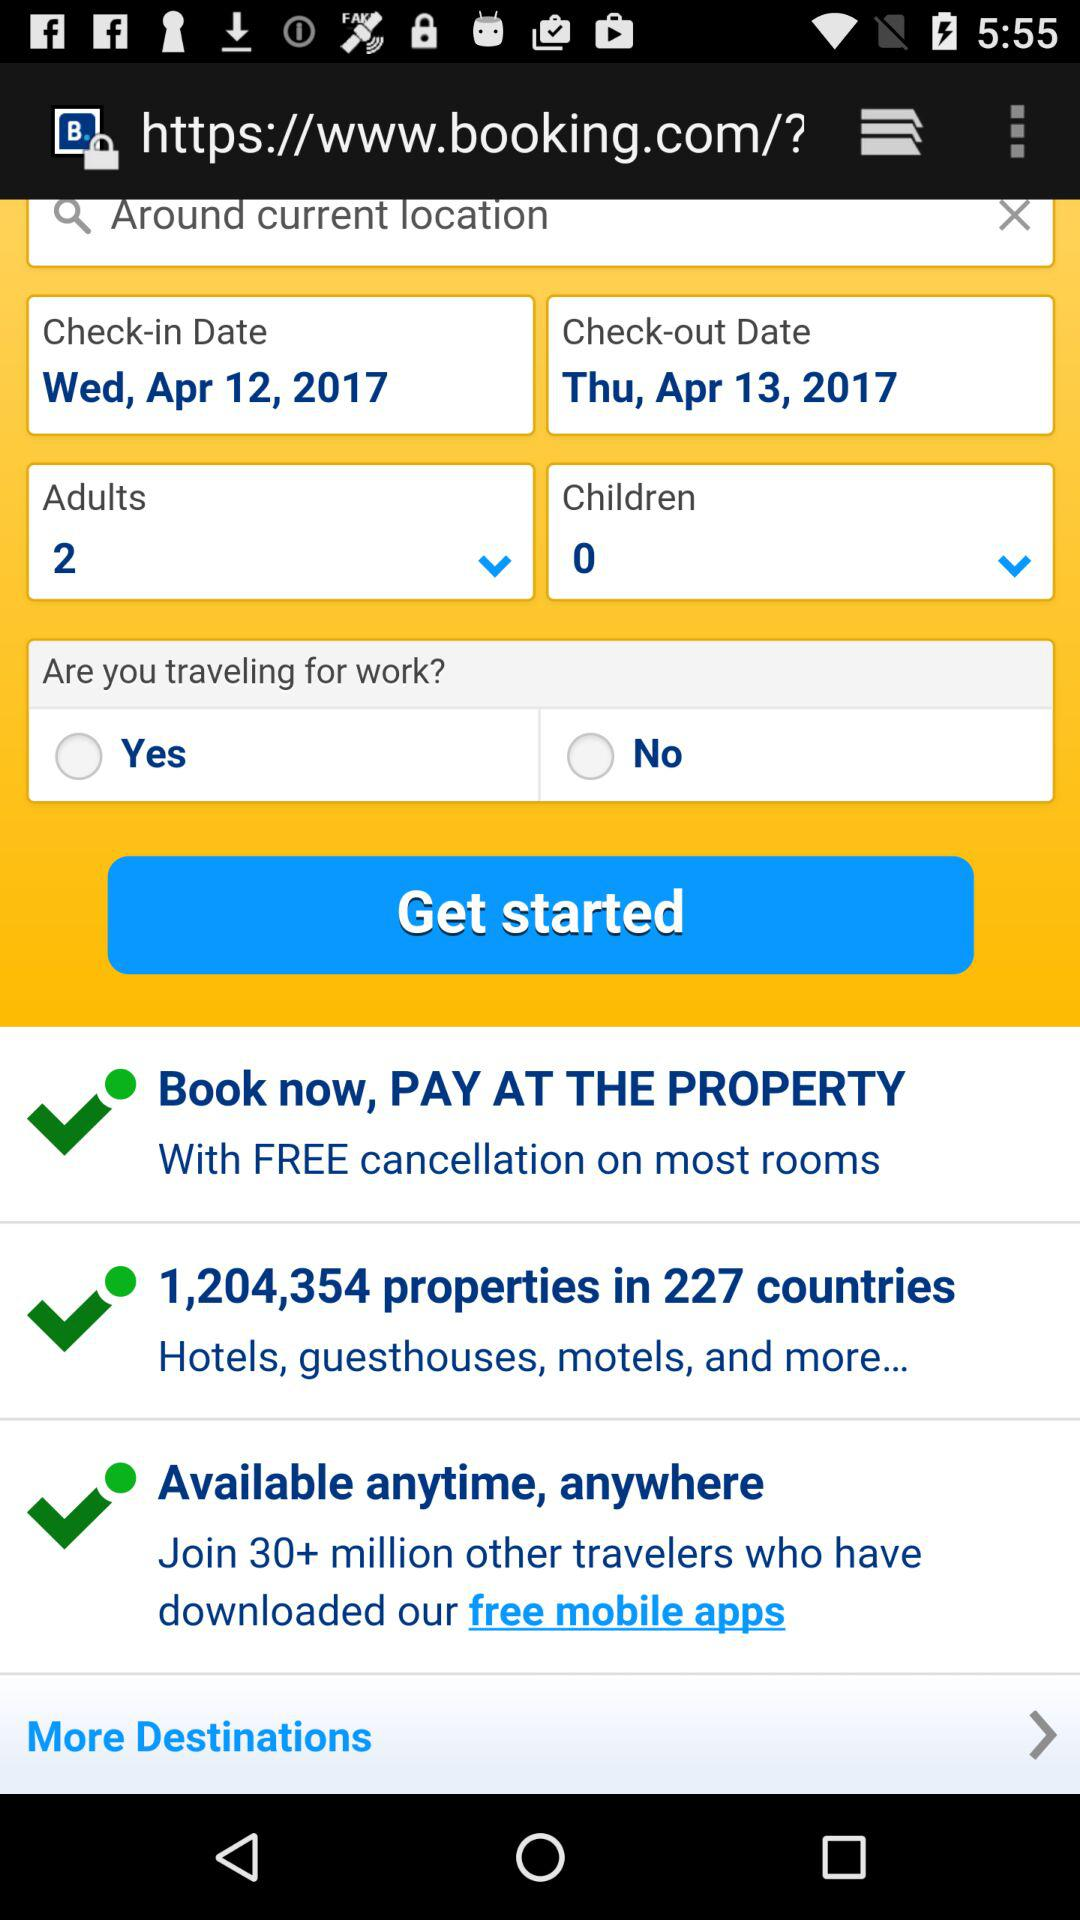How many adults are traveling?
Answer the question using a single word or phrase. 2 